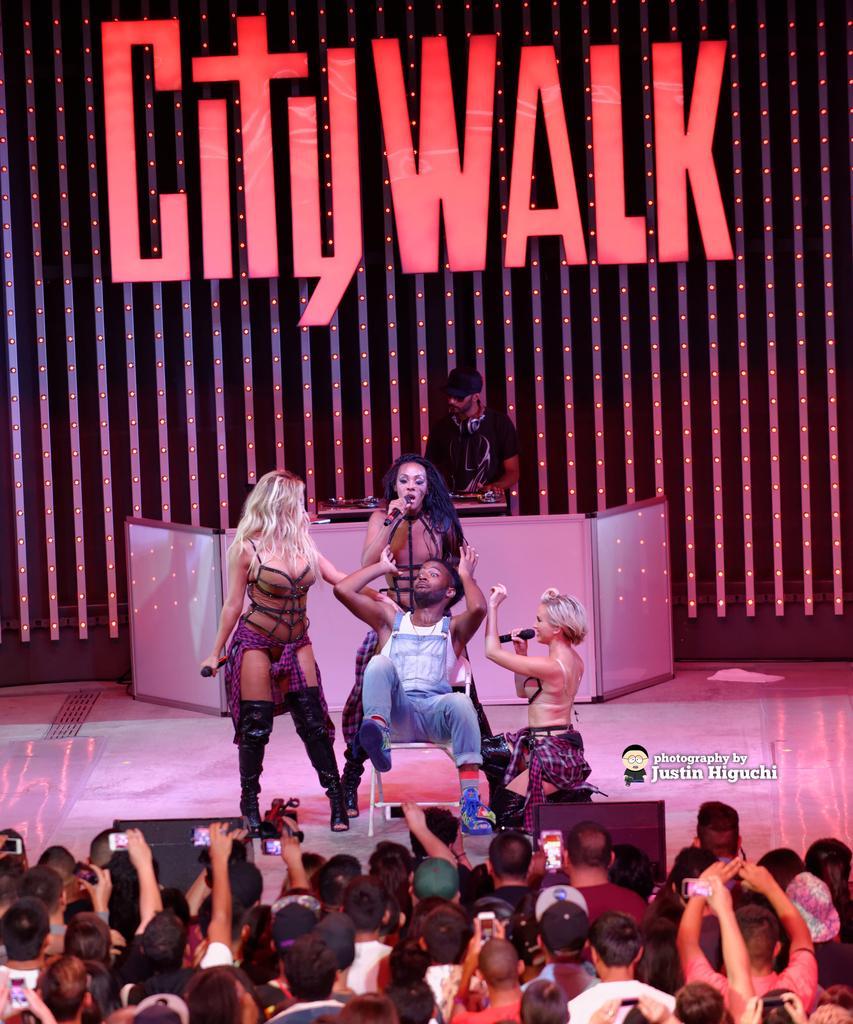Describe this image in one or two sentences. In this picture there is a man wearing white t-shirt is sitting on the chair. Beside there are three girl standing and sing a song. Behind there is a stage and a man wearing black t-shirt is playing music. On the banner board there is a "City walk" written on it. In the front bottom side there is a group of audience standing and taking the videos. 